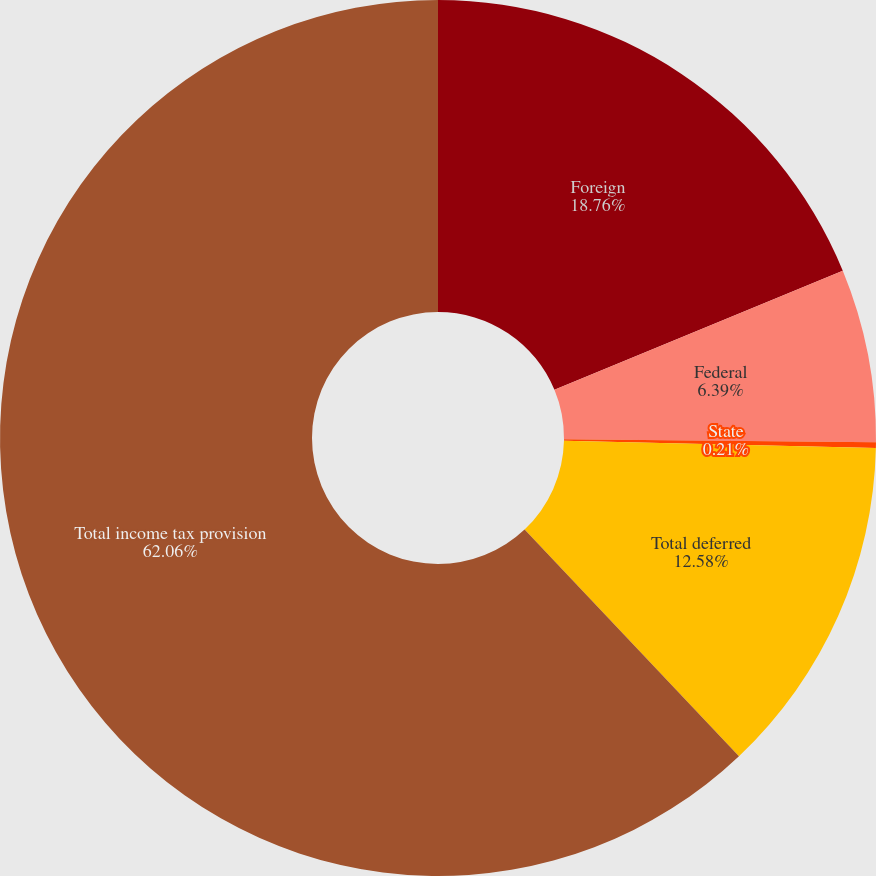Convert chart. <chart><loc_0><loc_0><loc_500><loc_500><pie_chart><fcel>Foreign<fcel>Federal<fcel>State<fcel>Total deferred<fcel>Total income tax provision<nl><fcel>18.76%<fcel>6.39%<fcel>0.21%<fcel>12.58%<fcel>62.05%<nl></chart> 